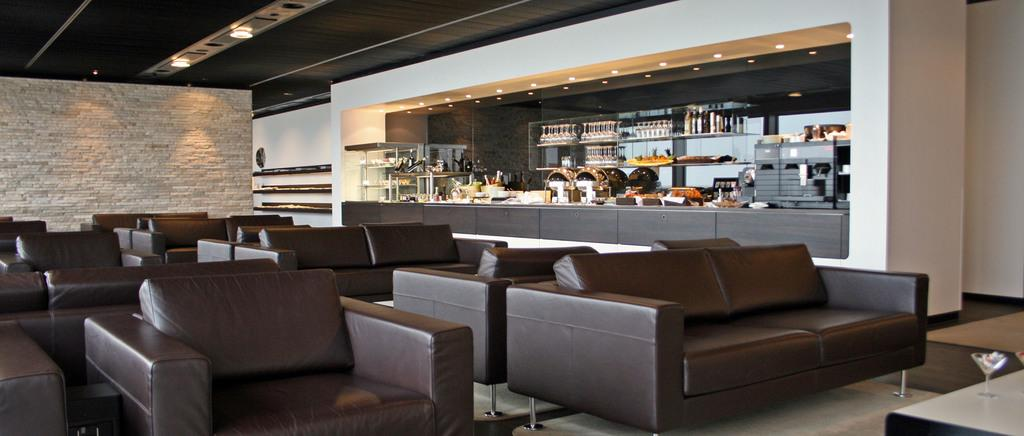What type of furniture is present in the image? There are couches in the image. What can be seen on the table in the image? There are 2 glasses on a table in the image. What is visible in the background of the image? There is a wall, many things on racks, and items on a counter top in the background. What type of lighting is present in the image? There are lights on the ceiling in the image. How does the yarn start to unravel in the image? There is no yarn present in the image, so it cannot start to unravel. What type of movement can be seen in the image? There is no movement of any objects or people visible in the image. 